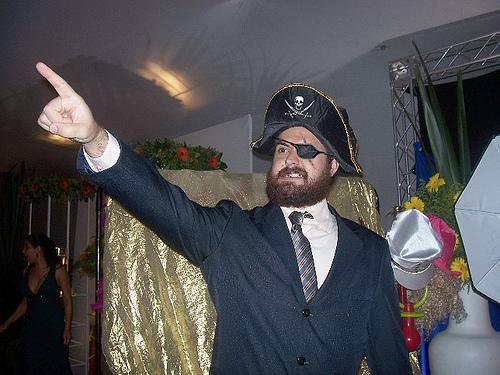If you had to guess which holiday would this most likely be? halloween 